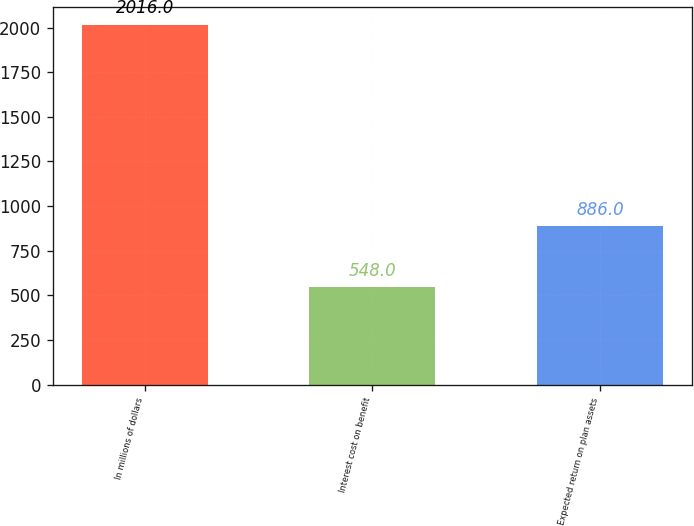<chart> <loc_0><loc_0><loc_500><loc_500><bar_chart><fcel>In millions of dollars<fcel>Interest cost on benefit<fcel>Expected return on plan assets<nl><fcel>2016<fcel>548<fcel>886<nl></chart> 